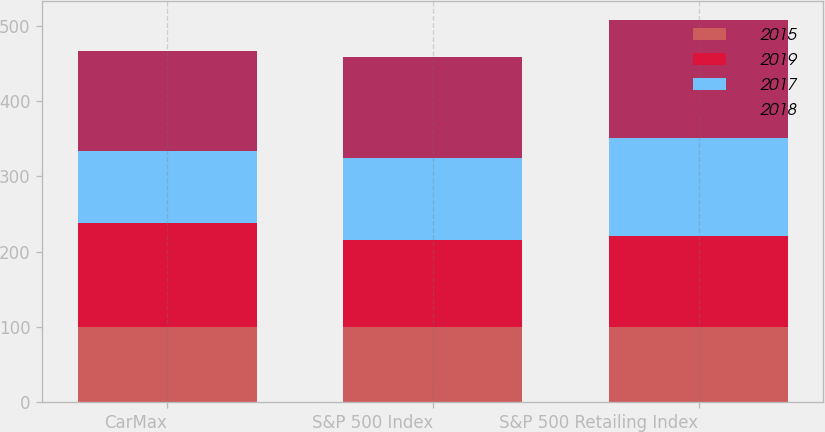Convert chart to OTSL. <chart><loc_0><loc_0><loc_500><loc_500><stacked_bar_chart><ecel><fcel>CarMax<fcel>S&P 500 Index<fcel>S&P 500 Retailing Index<nl><fcel>2015<fcel>100<fcel>100<fcel>100<nl><fcel>2019<fcel>138.57<fcel>115.51<fcel>120.98<nl><fcel>2017<fcel>95.52<fcel>108.36<fcel>129.75<nl><fcel>2018<fcel>133.26<fcel>135.42<fcel>157.02<nl></chart> 